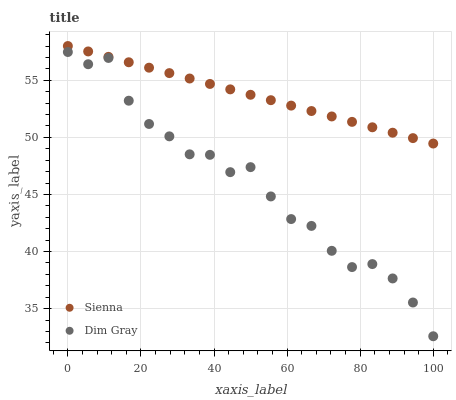Does Dim Gray have the minimum area under the curve?
Answer yes or no. Yes. Does Sienna have the maximum area under the curve?
Answer yes or no. Yes. Does Dim Gray have the maximum area under the curve?
Answer yes or no. No. Is Sienna the smoothest?
Answer yes or no. Yes. Is Dim Gray the roughest?
Answer yes or no. Yes. Is Dim Gray the smoothest?
Answer yes or no. No. Does Dim Gray have the lowest value?
Answer yes or no. Yes. Does Sienna have the highest value?
Answer yes or no. Yes. Does Dim Gray have the highest value?
Answer yes or no. No. Is Dim Gray less than Sienna?
Answer yes or no. Yes. Is Sienna greater than Dim Gray?
Answer yes or no. Yes. Does Dim Gray intersect Sienna?
Answer yes or no. No. 